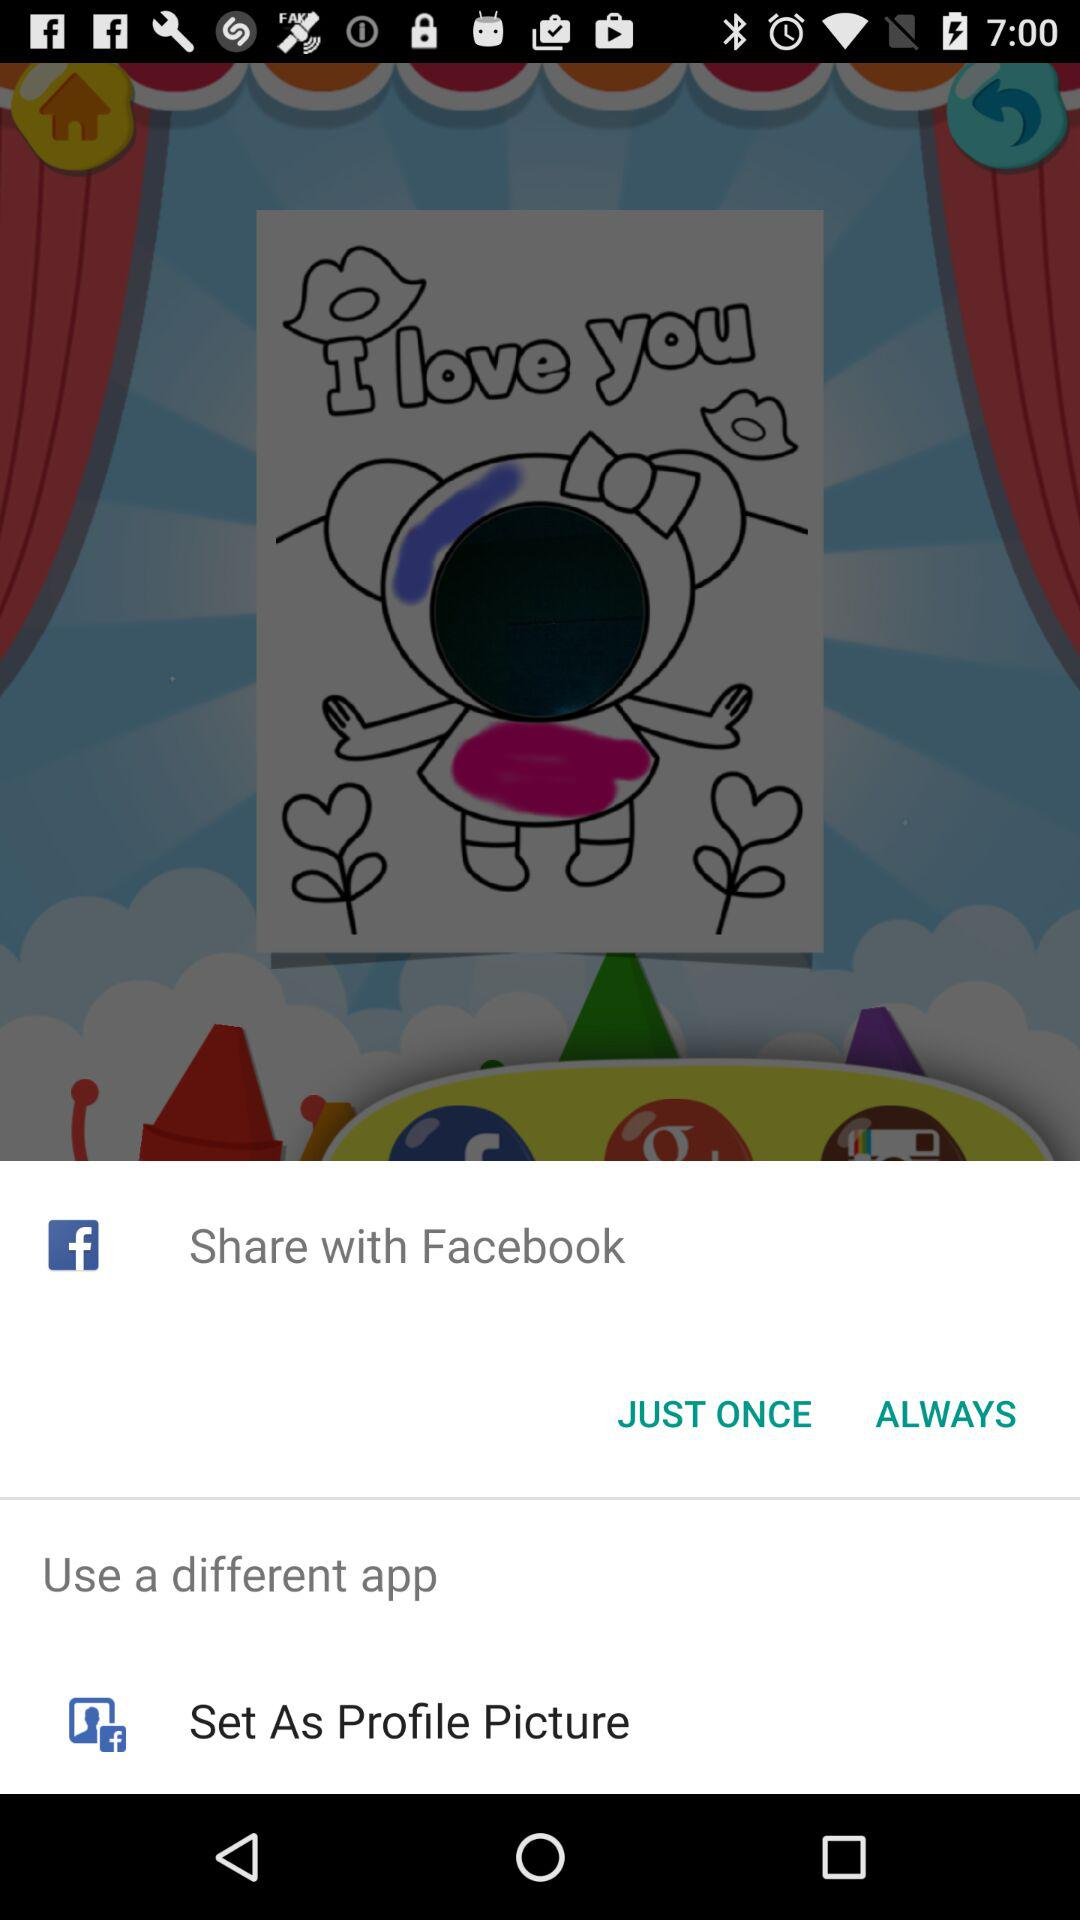Who is sharing the image?
When the provided information is insufficient, respond with <no answer>. <no answer> 